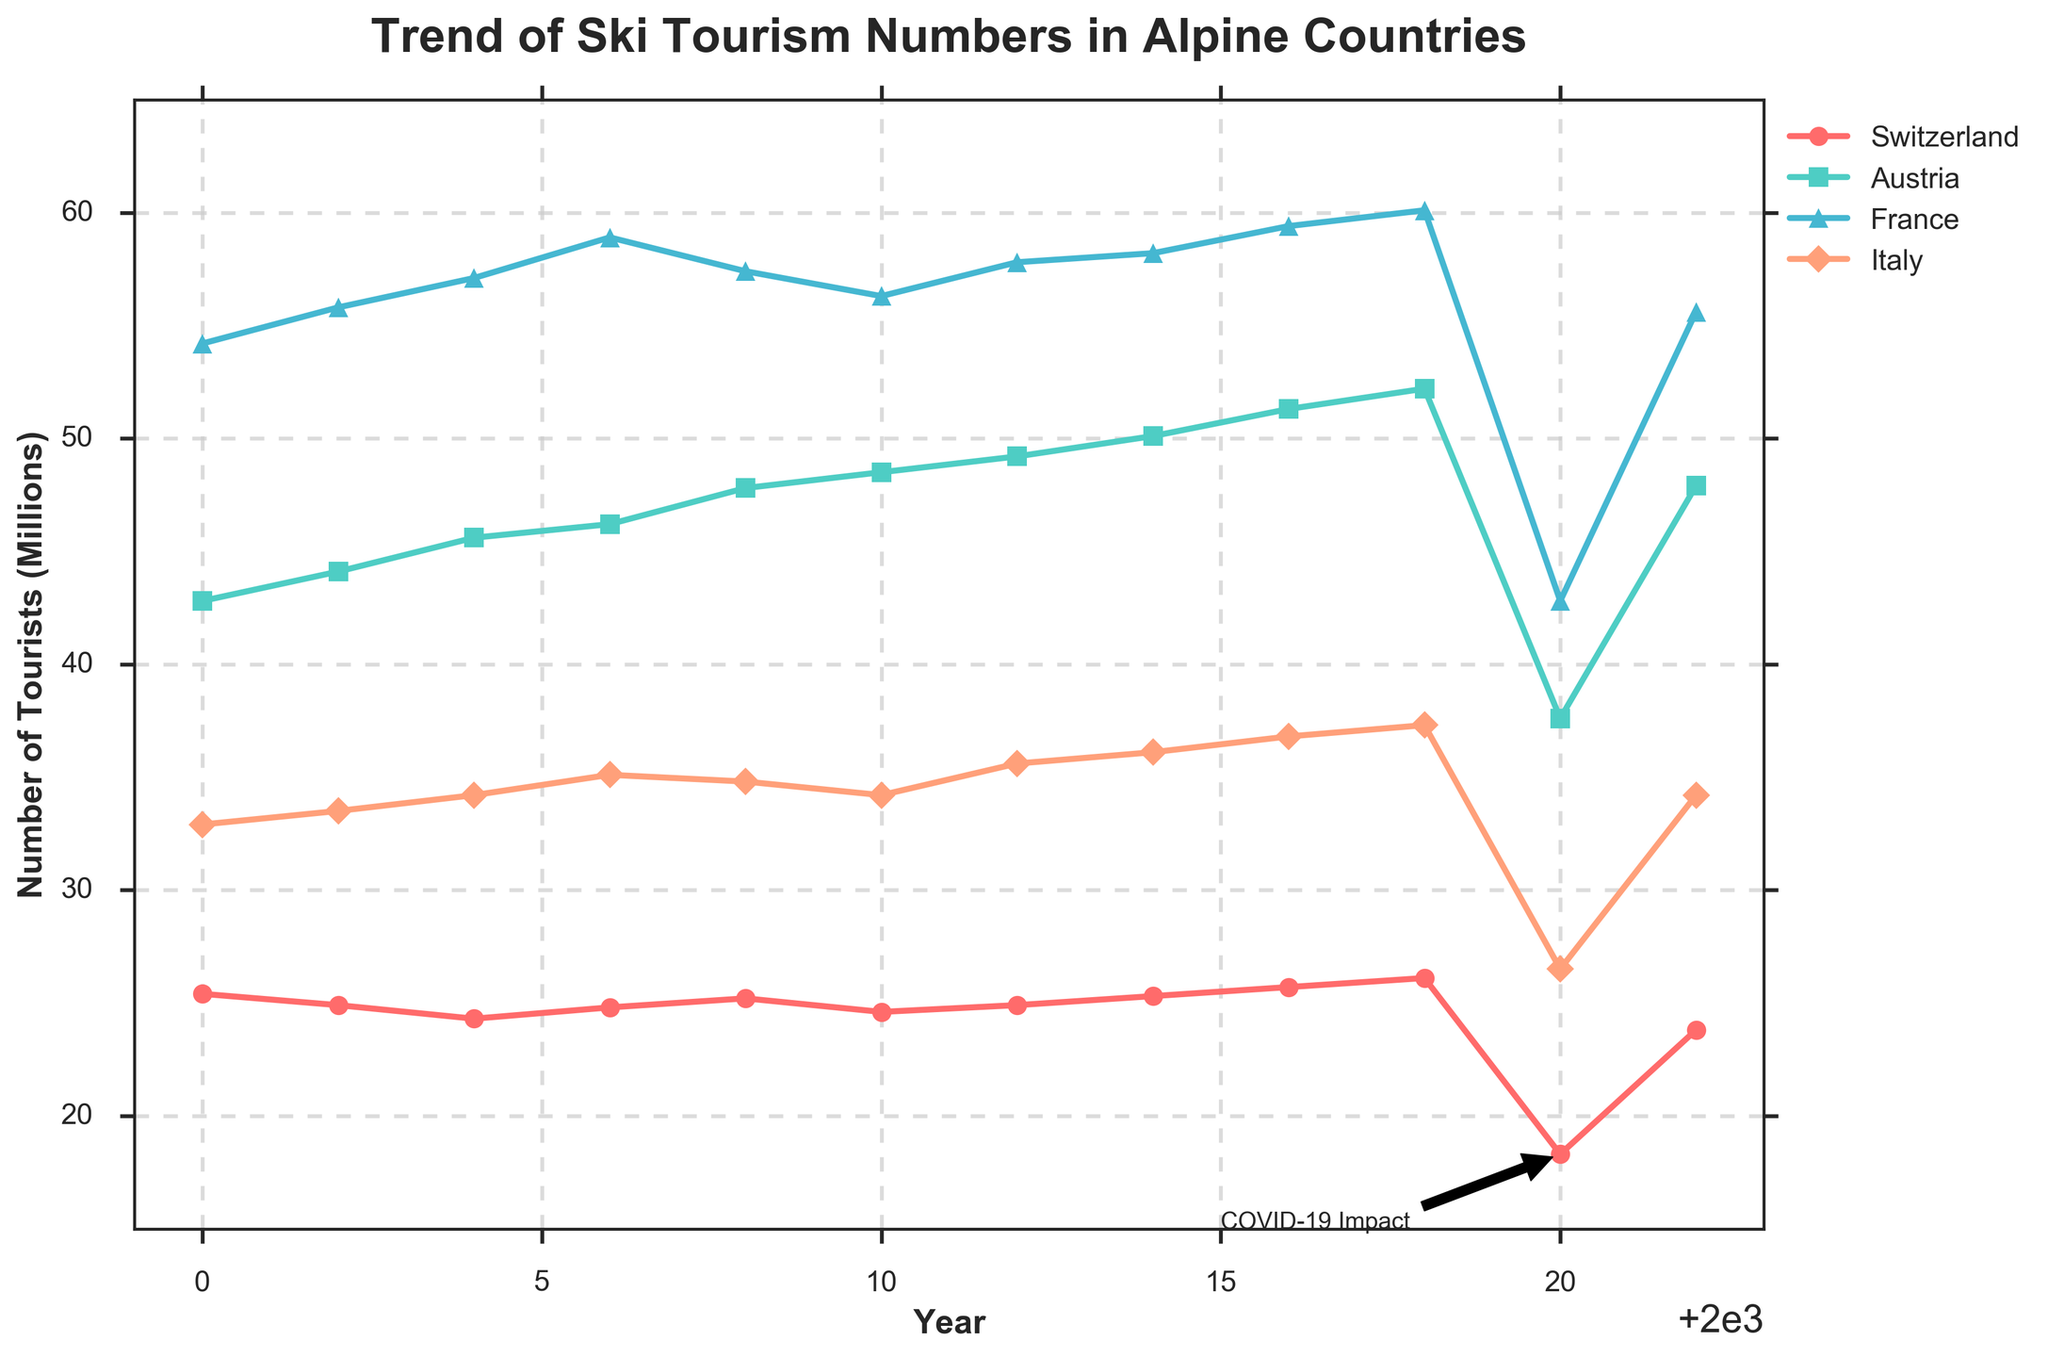What country had the highest number of ski tourists in 2022? By looking at the data points from 2022, identify the highest value among the countries listed.
Answer: France Which two countries had a decrease in ski tourists from 2018 to 2020, and what were the respective decreases? Check the data values for 2018 and 2020, subtract the 2020 value from the 2018 value for each country, and identify the countries with a decrease.
Answer: Switzerland (7.8 million), Austria (14.6 million), France (17.3 million), Italy (10.8 million) What is the general trend in the number of ski tourists in Italy from 2000 to 2018? Observe the Italy line from 2000 to 2018 and note its direction. The line shows an almost steady increase.
Answer: Increasing In which year did Switzerland experience its lowest number of ski tourists, and what was this number? Look for the lowest point in the Switzerland line on the chart and find the corresponding year and value.
Answer: 2020, 18.3 million How did the trend of ski tourism in France from 2000 to 2022 compare with that of Switzerland? Compare the shape and direction of the lines representing France and Switzerland over the period 2000 to 2022.
Answer: France shows a generally increasing trend with a dip in 2020, similar to Switzerland, but with higher values overall What can be inferred about the impact of COVID-19 on ski tourism in the year 2020 across all countries shown? Look at the sharp drops in the number of tourists for all four countries in 2020. The labeled annotation also points this out.
Answer: Significant negative impact Compare the number of ski tourists in Switzerland in 2008 with that in 2022. How much did it change, and what is the percentage change? Subtract the 2008 value from the 2022 value to get the change, then divide by the 2008 value and multiply by 100 to get the percentage change.
Answer: 1.4 million decrease, approximately 5.56% decrease Which country showed the most consistent increase in ski tourism numbers from 2000 to 2018? By observing the lines from 2000 to 2018, identify the country with the most steadily increasing trend.
Answer: Austria How many times did Switzerland's ski tourism numbers drop below 25 million from 2000 to 2022? Identify the years where the Switzerland line drops below 25 million.
Answer: 4 times (2002, 2004, 2006, 2010) What was the difference in the number of ski tourists between Austria and France in 2020? Subtract the number of tourists in Austria from those in France in the year 2020.
Answer: 5.2 million 